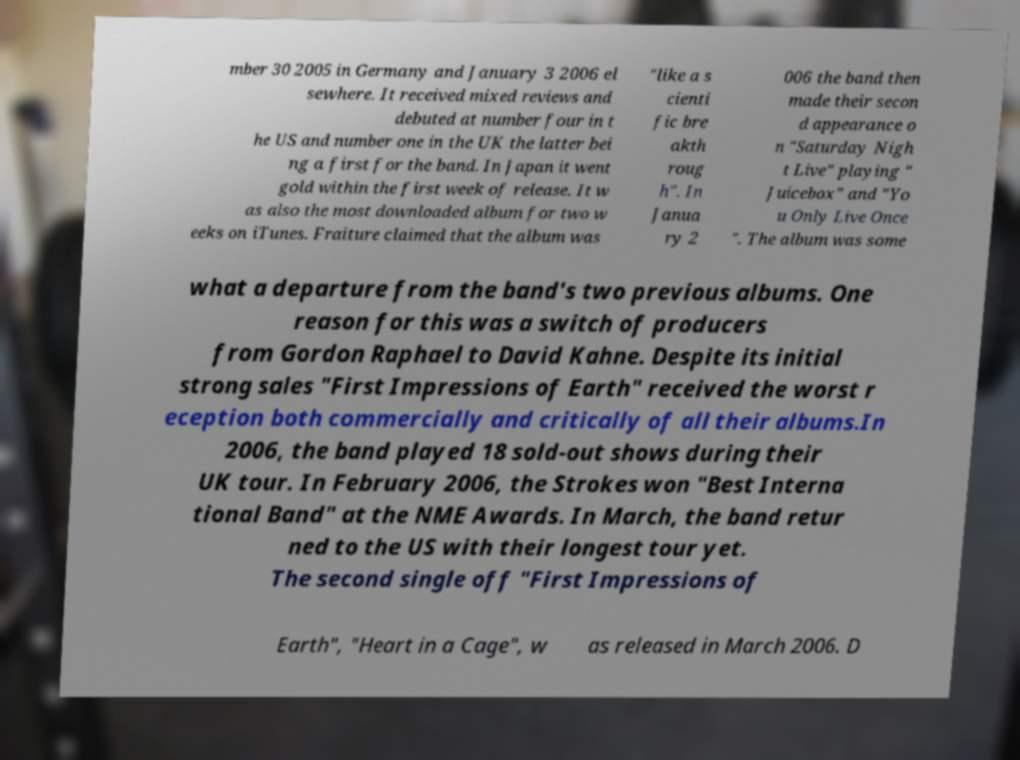I need the written content from this picture converted into text. Can you do that? mber 30 2005 in Germany and January 3 2006 el sewhere. It received mixed reviews and debuted at number four in t he US and number one in the UK the latter bei ng a first for the band. In Japan it went gold within the first week of release. It w as also the most downloaded album for two w eeks on iTunes. Fraiture claimed that the album was "like a s cienti fic bre akth roug h". In Janua ry 2 006 the band then made their secon d appearance o n "Saturday Nigh t Live" playing " Juicebox" and "Yo u Only Live Once ". The album was some what a departure from the band's two previous albums. One reason for this was a switch of producers from Gordon Raphael to David Kahne. Despite its initial strong sales "First Impressions of Earth" received the worst r eception both commercially and critically of all their albums.In 2006, the band played 18 sold-out shows during their UK tour. In February 2006, the Strokes won "Best Interna tional Band" at the NME Awards. In March, the band retur ned to the US with their longest tour yet. The second single off "First Impressions of Earth", "Heart in a Cage", w as released in March 2006. D 